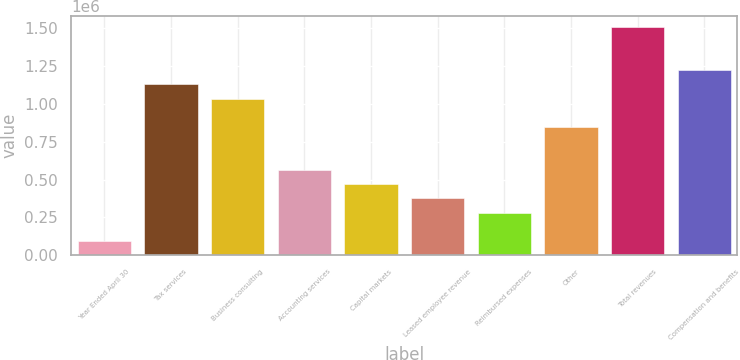Convert chart to OTSL. <chart><loc_0><loc_0><loc_500><loc_500><bar_chart><fcel>Year Ended April 30<fcel>Tax services<fcel>Business consulting<fcel>Accounting services<fcel>Capital markets<fcel>Leased employee revenue<fcel>Reimbursed expenses<fcel>Other<fcel>Total revenues<fcel>Compensation and benefits<nl><fcel>94177.1<fcel>1.13002e+06<fcel>1.03585e+06<fcel>565015<fcel>470848<fcel>376680<fcel>282512<fcel>847518<fcel>1.50669e+06<fcel>1.22419e+06<nl></chart> 